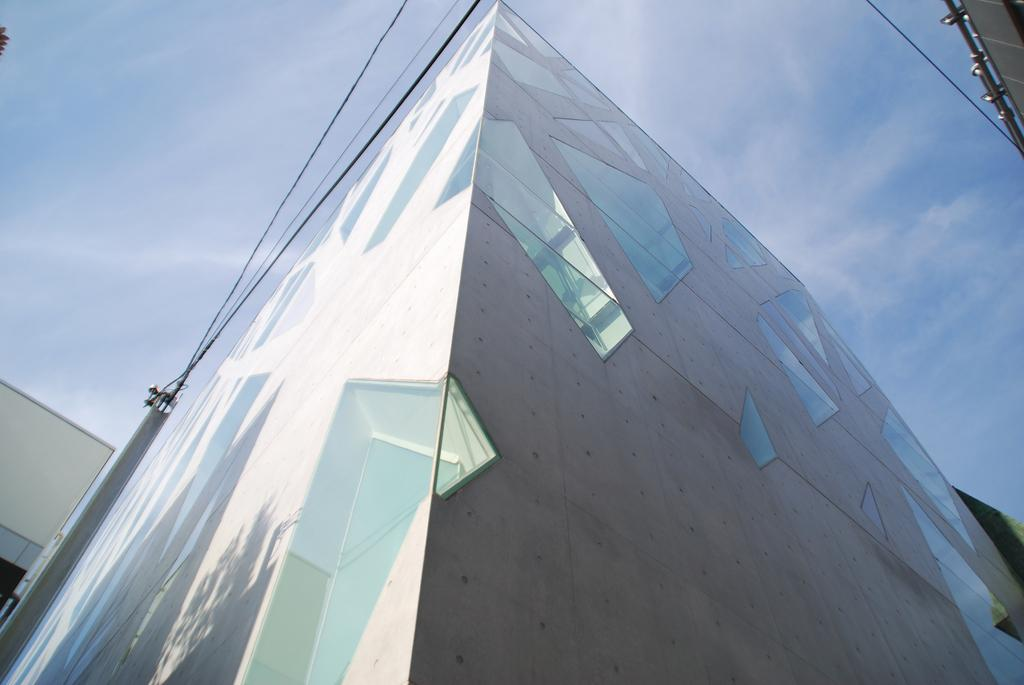What type of building is in the image? There is a skyscraper in the image. What can be seen in the sky in the image? The sky is blue and slightly cloudy in the image. Who is the owner of the bears in the image? There are no bears present in the image, so it is not possible to determine the owner. 